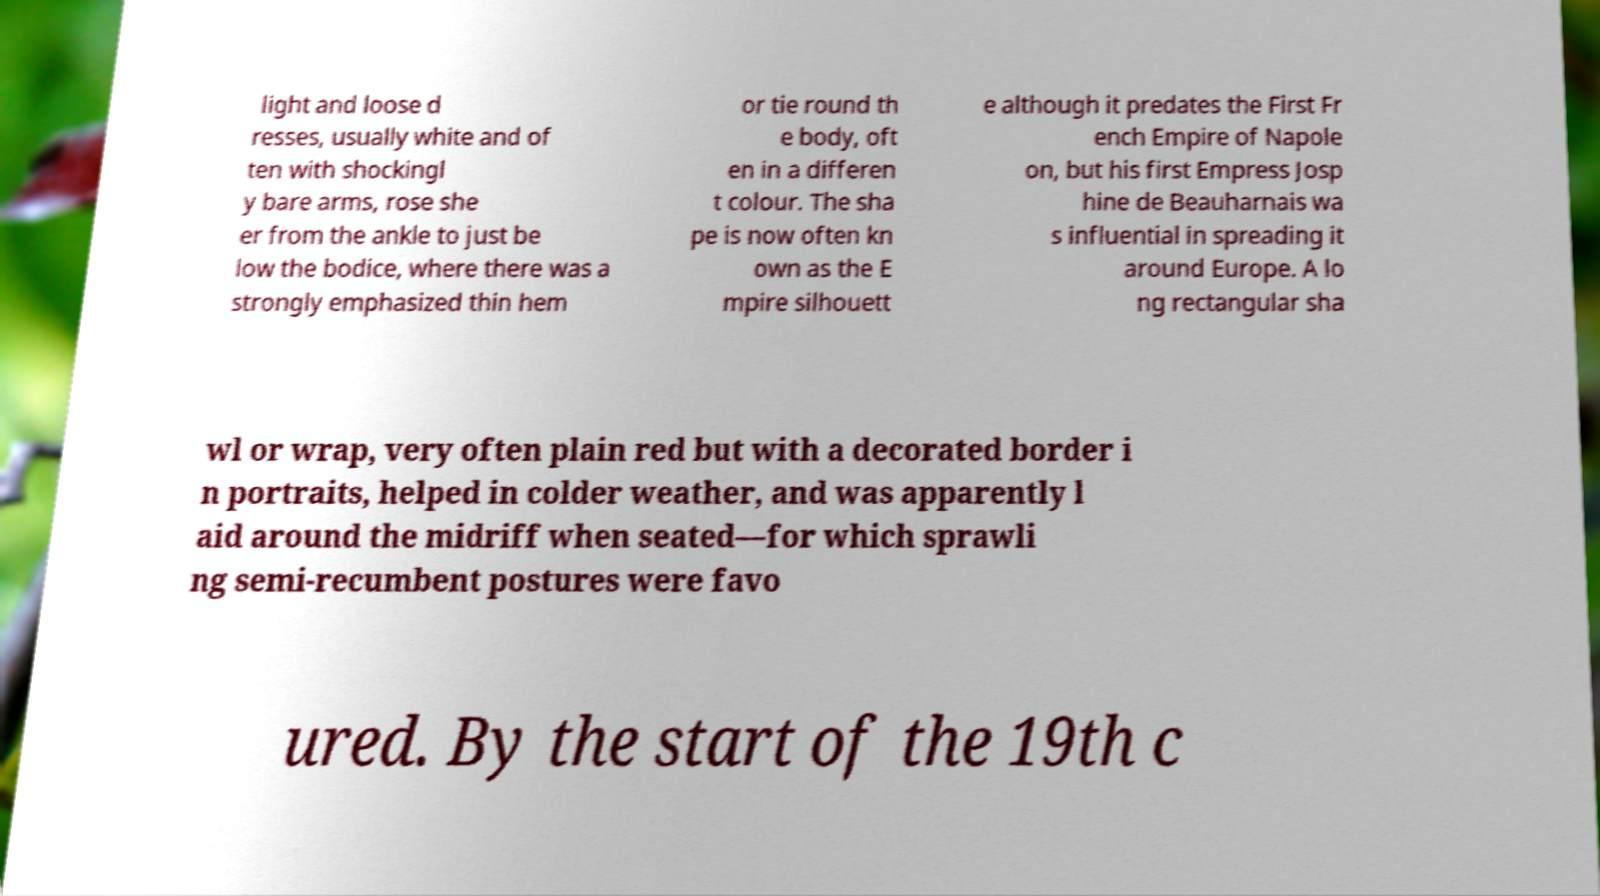Could you extract and type out the text from this image? light and loose d resses, usually white and of ten with shockingl y bare arms, rose she er from the ankle to just be low the bodice, where there was a strongly emphasized thin hem or tie round th e body, oft en in a differen t colour. The sha pe is now often kn own as the E mpire silhouett e although it predates the First Fr ench Empire of Napole on, but his first Empress Josp hine de Beauharnais wa s influential in spreading it around Europe. A lo ng rectangular sha wl or wrap, very often plain red but with a decorated border i n portraits, helped in colder weather, and was apparently l aid around the midriff when seated—for which sprawli ng semi-recumbent postures were favo ured. By the start of the 19th c 